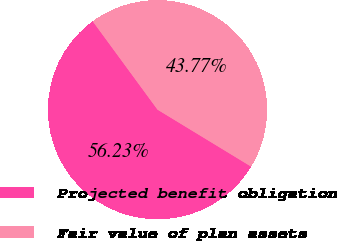<chart> <loc_0><loc_0><loc_500><loc_500><pie_chart><fcel>Projected benefit obligation<fcel>Fair value of plan assets<nl><fcel>56.23%<fcel>43.77%<nl></chart> 